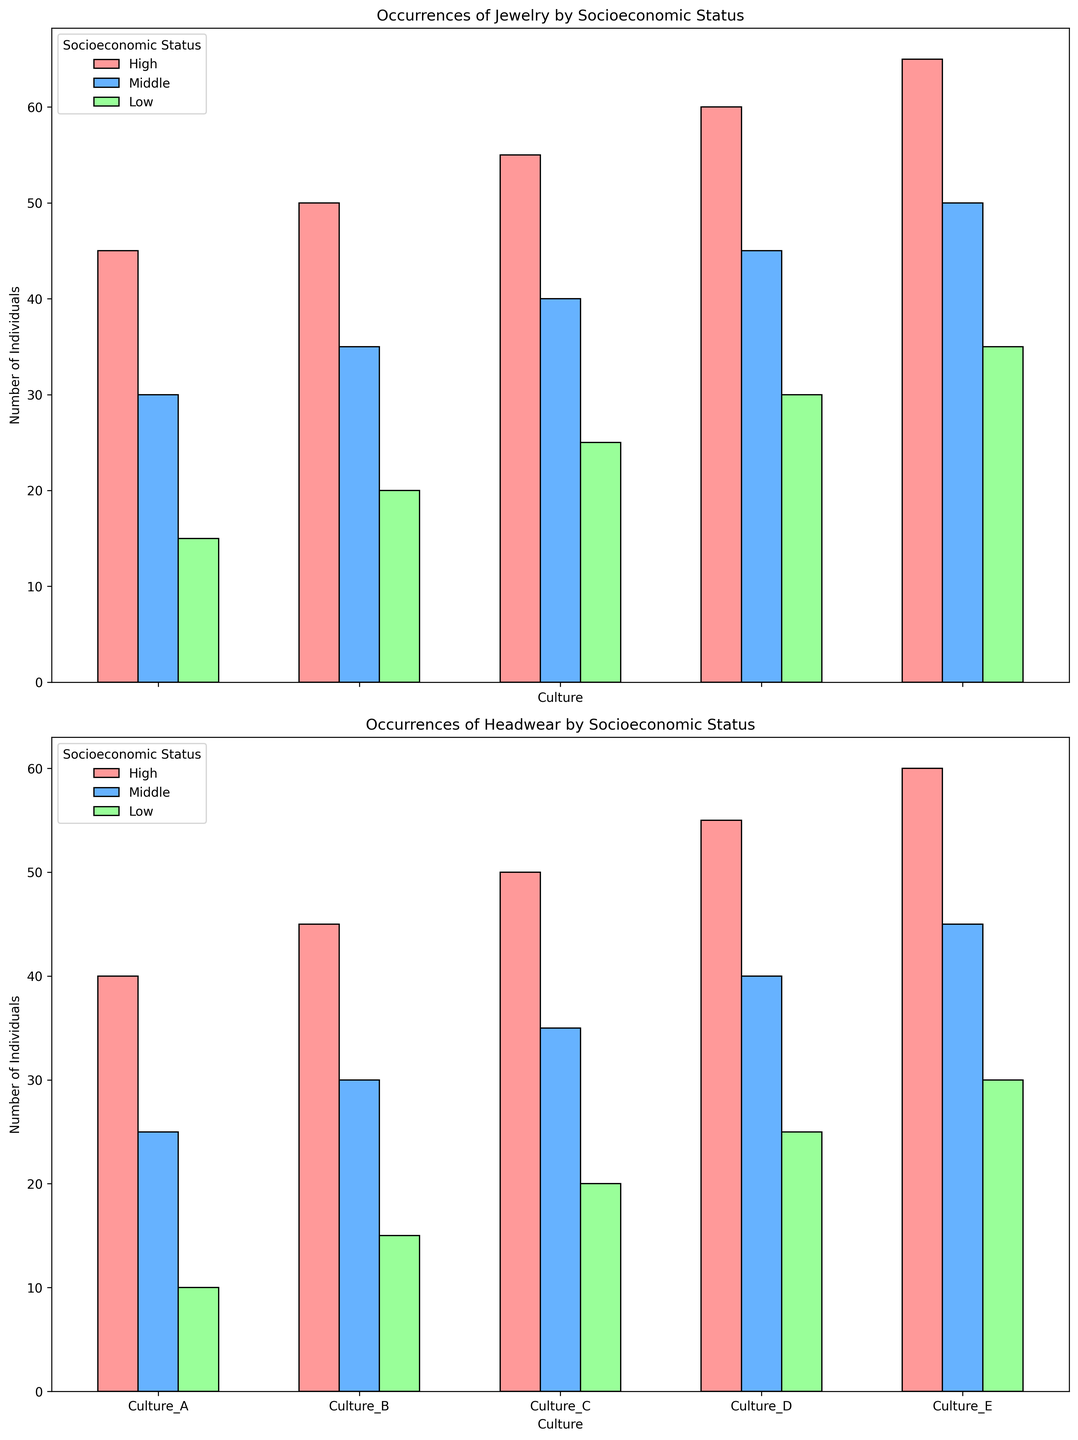What is the most common adornment type for high socioeconomic status individuals in Culture_A? According to the figure, for Culture_A, we see that high socioeconomic status individuals predominantly wear jewelry and headwear. Among these adornments, jewelry has 45 individuals while headwear has 40. Therefore, jewelry is the most common adornment.
Answer: Jewelry How does the occurrence of jewelry among middle socioeconomic status individuals compare between Culture_B and Culture_C? The figure shows that middle socioeconomic status individuals in Culture_B have 35 occurrences of jewelry, whereas those in Culture_C have 40 occurrences. By comparing these numbers, we can see that Culture_C has a higher occurrence.
Answer: Culture_C has a higher occurrence Which culture exhibits the highest number of individuals wearing headwear in the low socioeconomic status group? Referring to the figure, we can see that for the low socioeconomic status group, Culture_A has 10, Culture_B has 15, Culture_C has 20, Culture_D has 25, and Culture_E has 30 individuals wearing headwear. Therefore, Culture_E exhibits the highest number.
Answer: Culture_E What is the total number of individuals wearing headwear in Culture_D across all socioeconomic statuses? The total number of individuals wearing headwear in Culture_D is the sum of those in the high, middle, and low socioeconomic statuses. According to the figure, these are 55 (high), 40 (middle), and 25 (low). Adding these gives 55 + 40 + 25 = 120.
Answer: 120 Which socioeconomic status group in Culture_E has the lowest occurrence of jewelry, and what is that number? From the figure, we observe the occurrences of jewelry in Culture_E across different statuses: high (65), middle (50), and low (35). The lowest occurrence is in the low socioeconomic status group with 35 individuals.
Answer: Low, 35 Is there a culture in which the number of individuals wearing jewelry in the middle socioeconomic status group exceeds that of the high socioeconomic status group? Upon examining the figure, we see that in every culture (Cultures A, B, C, D, E), the number of individuals in the high socioeconomic status group is greater than in the middle group for jewelry. Therefore, there is no culture with a higher middle status occurrence than high.
Answer: No Compare the difference in the number of individuals wearing headwear between high and low socioeconomic statuses in Culture_A. The occurrences of headwear in Culture_A are 40 (high) and 10 (low). The difference is calculated as 40 - 10 = 30.
Answer: 30 What is the average number of individuals wearing jewelry in the high socioeconomic status group across all cultures? To find the average, sum the occurrences of jewelry in the high socioeconomic status group for all cultures: 45 (A), 50 (B), 55 (C), 60 (D), 65 (E). The total is 45 + 50 + 55 + 60 + 65 = 275. Dividing by the number of cultures (5), we get 275 / 5 = 55.
Answer: 55 